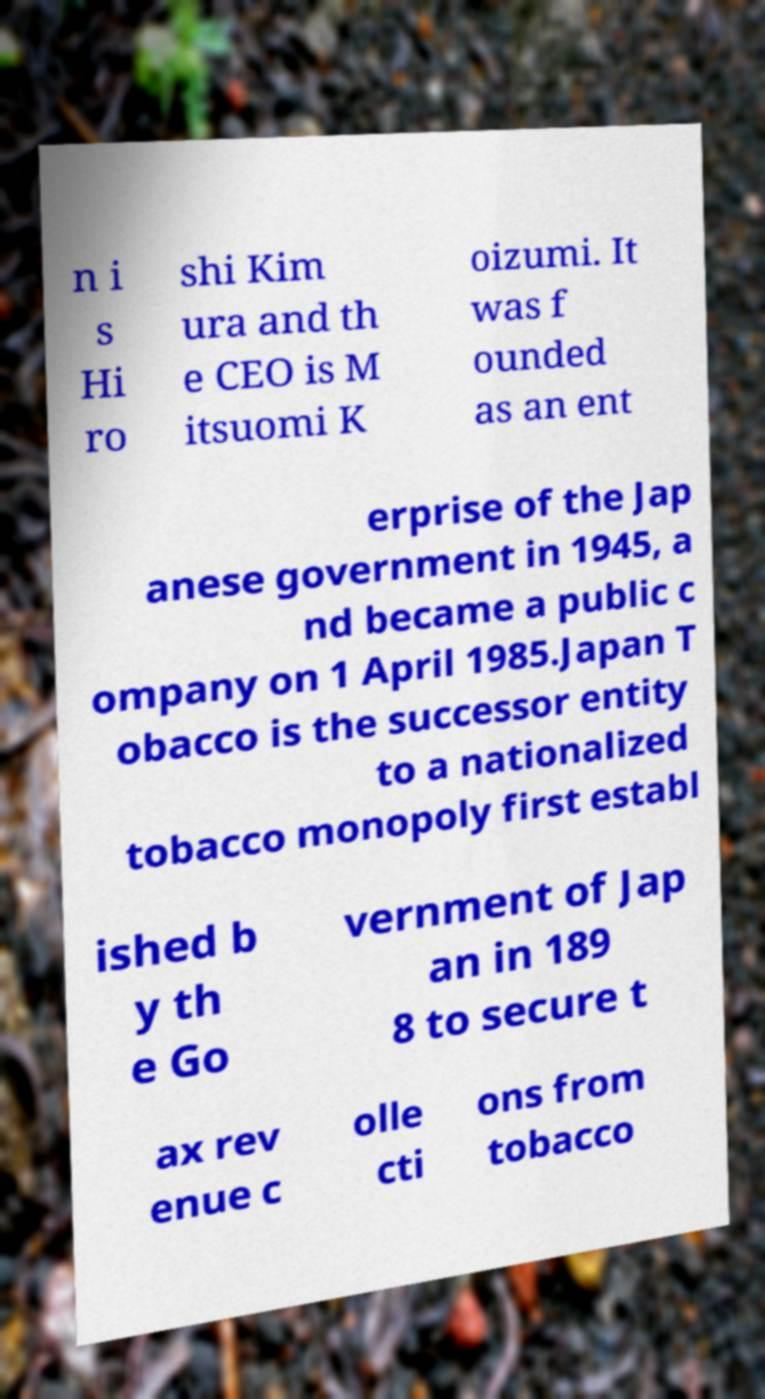Please identify and transcribe the text found in this image. n i s Hi ro shi Kim ura and th e CEO is M itsuomi K oizumi. It was f ounded as an ent erprise of the Jap anese government in 1945, a nd became a public c ompany on 1 April 1985.Japan T obacco is the successor entity to a nationalized tobacco monopoly first establ ished b y th e Go vernment of Jap an in 189 8 to secure t ax rev enue c olle cti ons from tobacco 